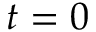<formula> <loc_0><loc_0><loc_500><loc_500>t = 0</formula> 